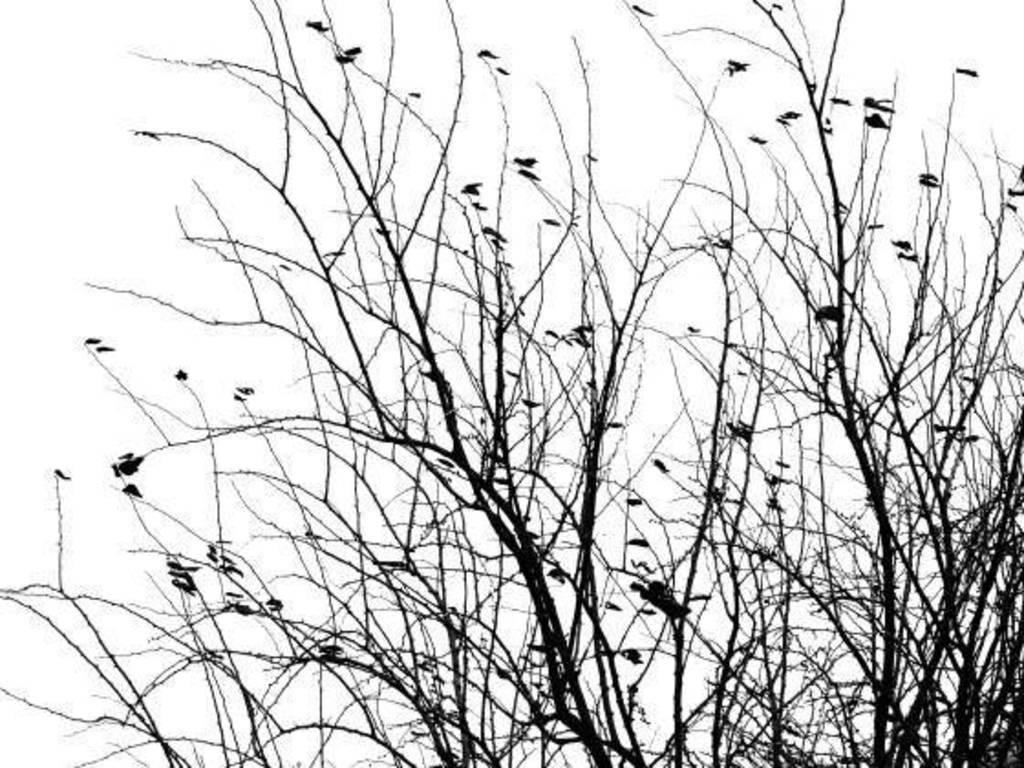What type of animals can be seen in the image? There are birds in the image. Where are the birds located? The birds are on a tree. What color is the background of the image? The background of the image is white. What type of drum can be seen in the image? There is no drum present in the image; it features birds on a tree with a white background. 